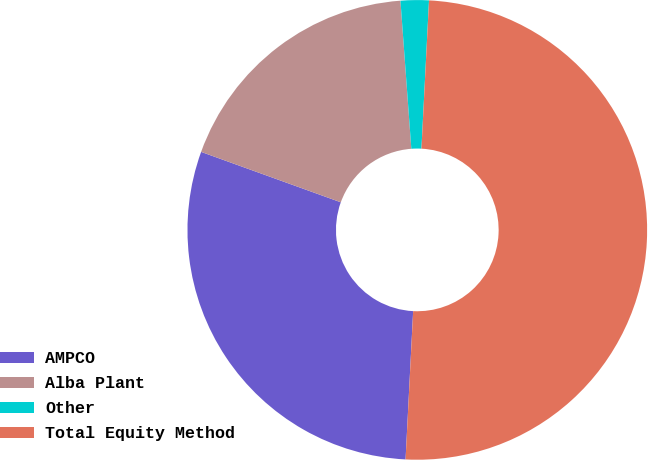Convert chart to OTSL. <chart><loc_0><loc_0><loc_500><loc_500><pie_chart><fcel>AMPCO<fcel>Alba Plant<fcel>Other<fcel>Total Equity Method<nl><fcel>29.7%<fcel>18.32%<fcel>1.98%<fcel>50.0%<nl></chart> 